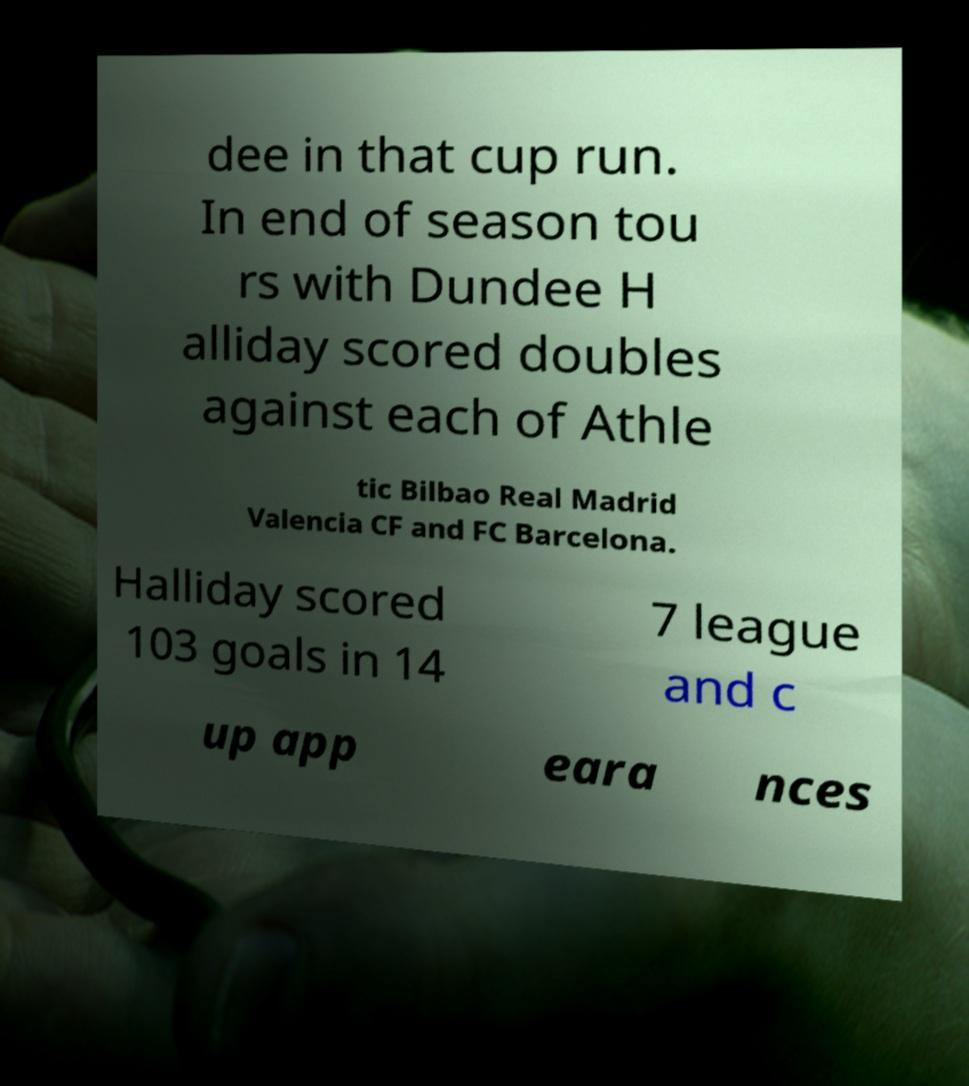For documentation purposes, I need the text within this image transcribed. Could you provide that? dee in that cup run. In end of season tou rs with Dundee H alliday scored doubles against each of Athle tic Bilbao Real Madrid Valencia CF and FC Barcelona. Halliday scored 103 goals in 14 7 league and c up app eara nces 